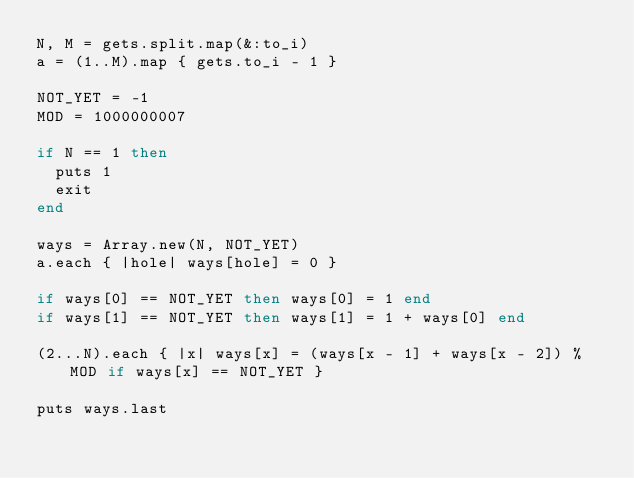Convert code to text. <code><loc_0><loc_0><loc_500><loc_500><_Ruby_>N, M = gets.split.map(&:to_i)
a = (1..M).map { gets.to_i - 1 }

NOT_YET = -1
MOD = 1000000007

if N == 1 then
  puts 1
  exit
end

ways = Array.new(N, NOT_YET)
a.each { |hole| ways[hole] = 0 }

if ways[0] == NOT_YET then ways[0] = 1 end
if ways[1] == NOT_YET then ways[1] = 1 + ways[0] end

(2...N).each { |x| ways[x] = (ways[x - 1] + ways[x - 2]) % MOD if ways[x] == NOT_YET }

puts ways.last
  
</code> 